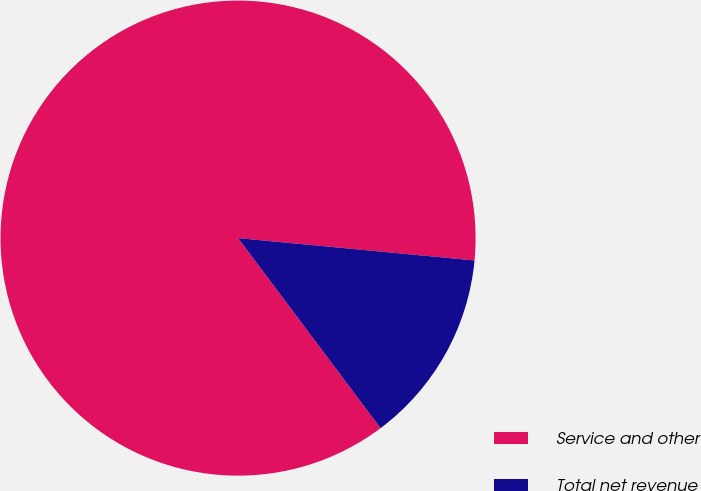<chart> <loc_0><loc_0><loc_500><loc_500><pie_chart><fcel>Service and other<fcel>Total net revenue<nl><fcel>86.74%<fcel>13.26%<nl></chart> 